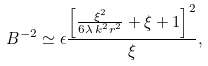Convert formula to latex. <formula><loc_0><loc_0><loc_500><loc_500>B ^ { - 2 } \simeq \epsilon \frac { \left [ \frac { \xi ^ { 2 } } { 6 \lambda \, k ^ { 2 } r ^ { 2 } } + \xi + 1 \right ] ^ { 2 } } { \xi } ,</formula> 